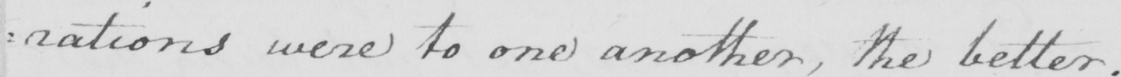What text is written in this handwritten line? : rations were to one another , the better . 